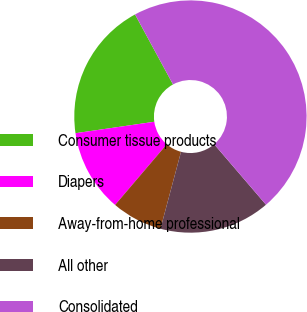Convert chart. <chart><loc_0><loc_0><loc_500><loc_500><pie_chart><fcel>Consumer tissue products<fcel>Diapers<fcel>Away-from-home professional<fcel>All other<fcel>Consolidated<nl><fcel>19.38%<fcel>11.47%<fcel>7.08%<fcel>15.43%<fcel>46.63%<nl></chart> 